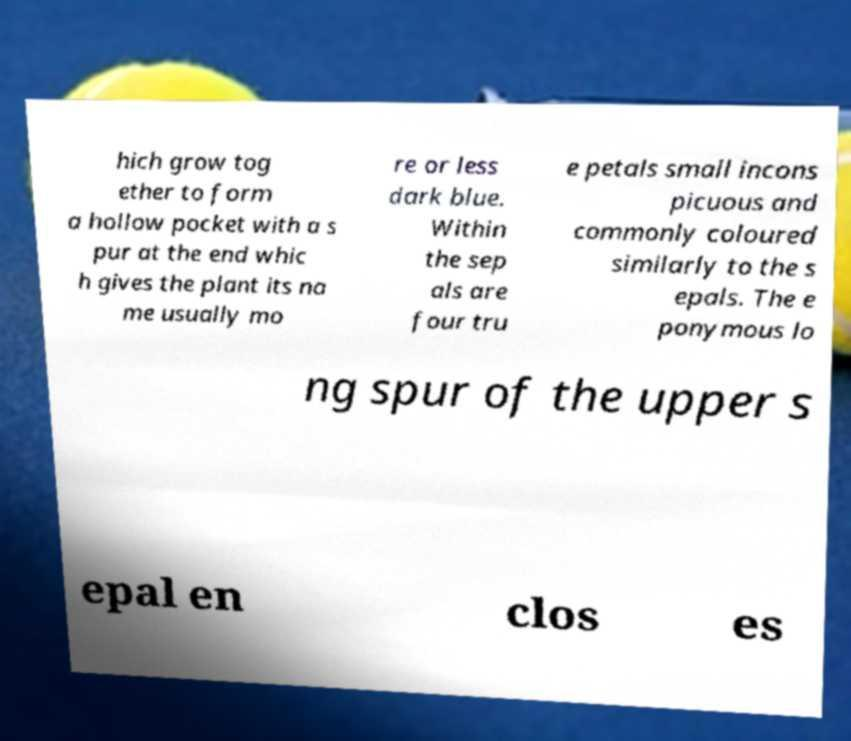Could you assist in decoding the text presented in this image and type it out clearly? hich grow tog ether to form a hollow pocket with a s pur at the end whic h gives the plant its na me usually mo re or less dark blue. Within the sep als are four tru e petals small incons picuous and commonly coloured similarly to the s epals. The e ponymous lo ng spur of the upper s epal en clos es 